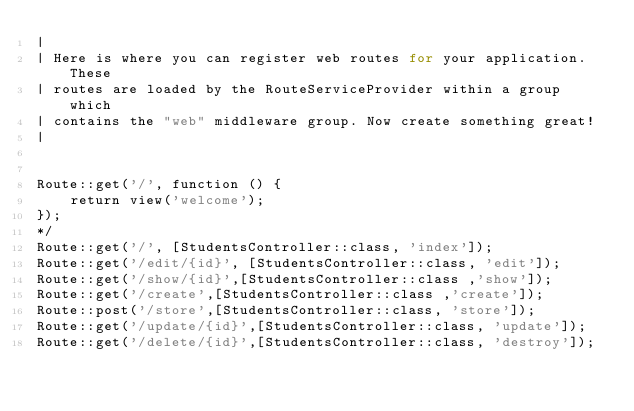Convert code to text. <code><loc_0><loc_0><loc_500><loc_500><_PHP_>|
| Here is where you can register web routes for your application. These
| routes are loaded by the RouteServiceProvider within a group which
| contains the "web" middleware group. Now create something great!
|


Route::get('/', function () {
    return view('welcome');
});
*/
Route::get('/', [StudentsController::class, 'index']);
Route::get('/edit/{id}', [StudentsController::class, 'edit']);
Route::get('/show/{id}',[StudentsController::class ,'show']);
Route::get('/create',[StudentsController::class ,'create']);
Route::post('/store',[StudentsController::class, 'store']);
Route::get('/update/{id}',[StudentsController::class, 'update']);
Route::get('/delete/{id}',[StudentsController::class, 'destroy']);

</code> 